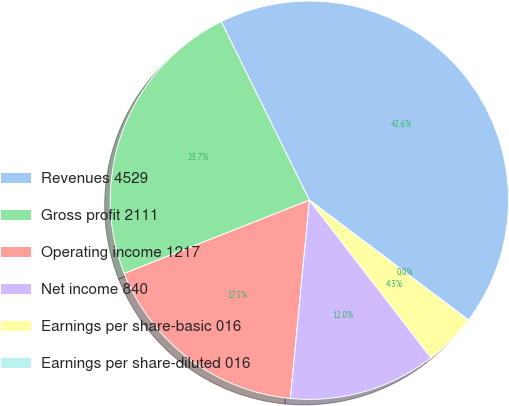<chart> <loc_0><loc_0><loc_500><loc_500><pie_chart><fcel>Revenues 4529<fcel>Gross profit 2111<fcel>Operating income 1217<fcel>Net income 840<fcel>Earnings per share-basic 016<fcel>Earnings per share-diluted 016<nl><fcel>42.58%<fcel>23.69%<fcel>17.48%<fcel>11.98%<fcel>4.26%<fcel>0.0%<nl></chart> 